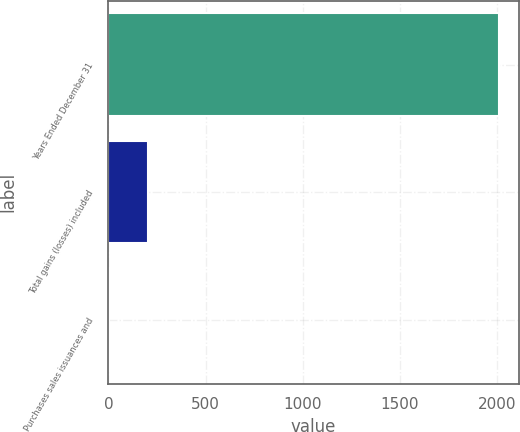<chart> <loc_0><loc_0><loc_500><loc_500><bar_chart><fcel>Years Ended December 31<fcel>Total gains (losses) included<fcel>Purchases sales issuances and<nl><fcel>2010<fcel>203.7<fcel>3<nl></chart> 